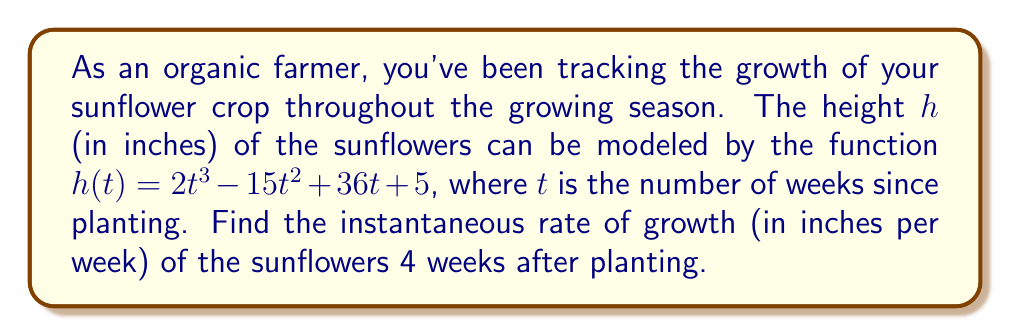Solve this math problem. To find the instantaneous rate of growth, we need to calculate the derivative of the height function $h(t)$ and evaluate it at $t = 4$ weeks. Let's follow these steps:

1) The given function is $h(t) = 2t^3 - 15t^2 + 36t + 5$

2) To find the derivative $h'(t)$, we apply the power rule and constant rule:
   $$h'(t) = 6t^2 - 30t + 36$$

3) This derivative $h'(t)$ represents the instantaneous rate of growth at any time $t$.

4) To find the rate of growth at 4 weeks, we substitute $t = 4$ into $h'(t)$:
   $$h'(4) = 6(4)^2 - 30(4) + 36$$
   $$= 6(16) - 120 + 36$$
   $$= 96 - 120 + 36$$
   $$= 12$$

Therefore, the instantaneous rate of growth 4 weeks after planting is 12 inches per week.
Answer: $12$ inches per week 